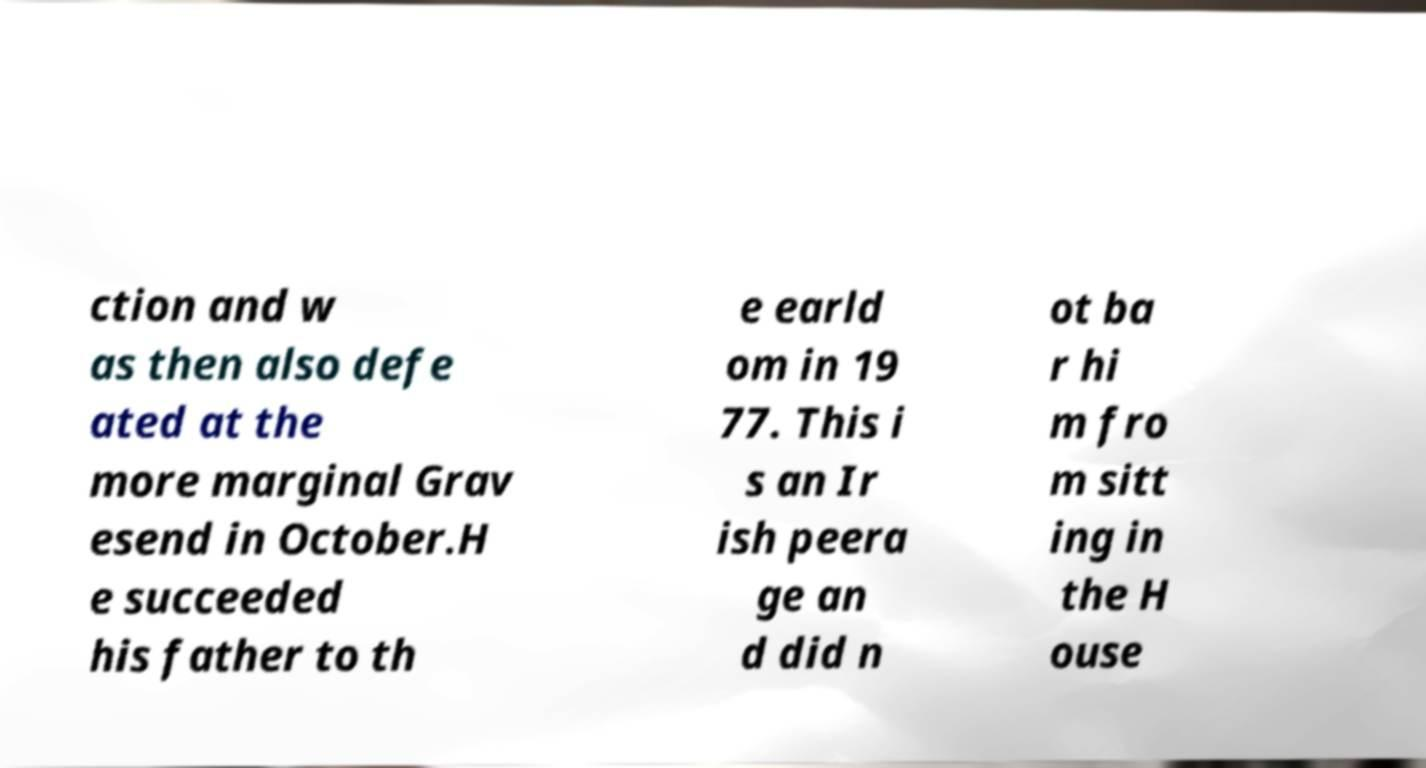What messages or text are displayed in this image? I need them in a readable, typed format. ction and w as then also defe ated at the more marginal Grav esend in October.H e succeeded his father to th e earld om in 19 77. This i s an Ir ish peera ge an d did n ot ba r hi m fro m sitt ing in the H ouse 